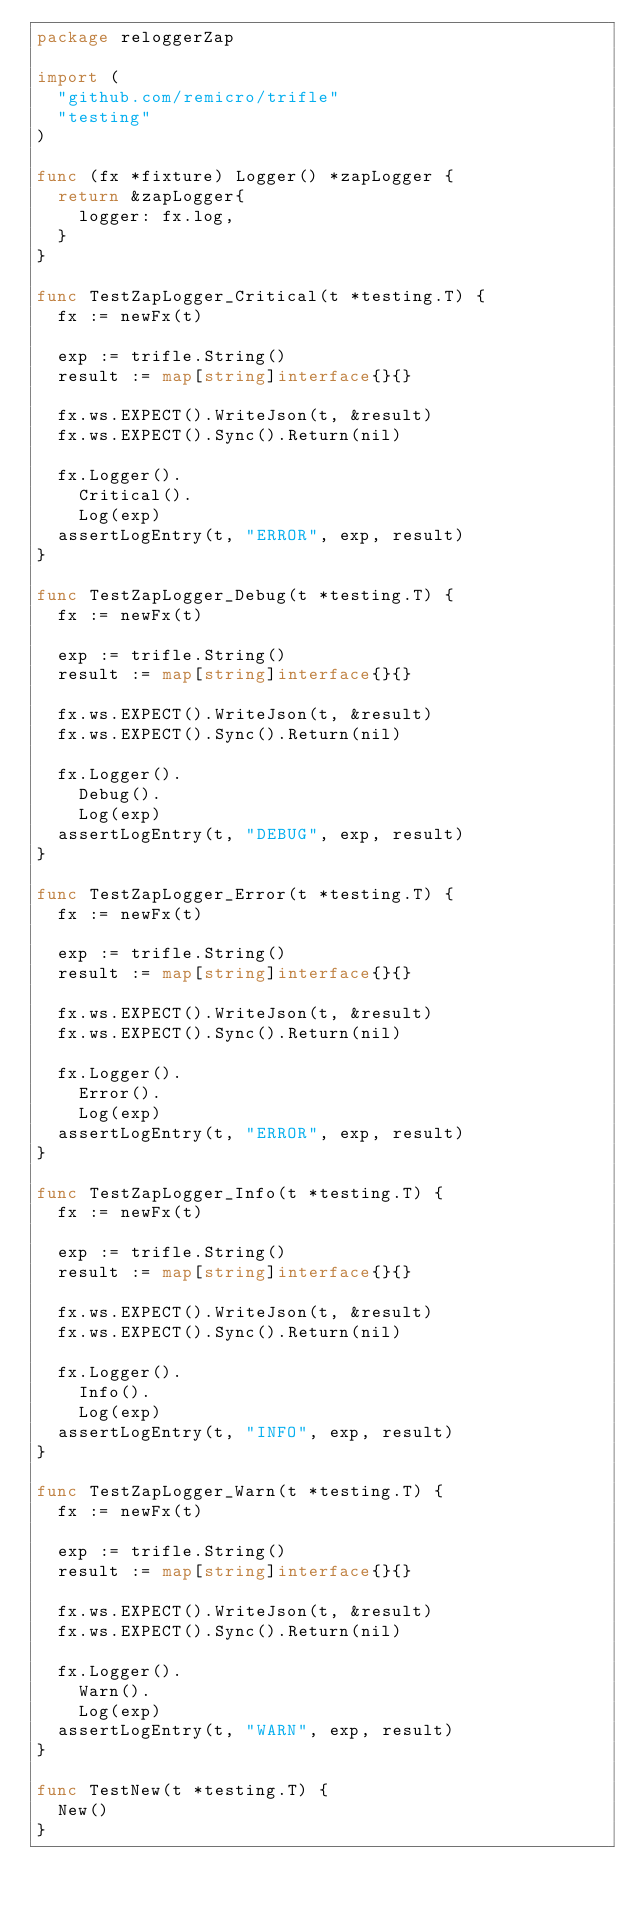Convert code to text. <code><loc_0><loc_0><loc_500><loc_500><_Go_>package reloggerZap

import (
	"github.com/remicro/trifle"
	"testing"
)

func (fx *fixture) Logger() *zapLogger {
	return &zapLogger{
		logger: fx.log,
	}
}

func TestZapLogger_Critical(t *testing.T) {
	fx := newFx(t)

	exp := trifle.String()
	result := map[string]interface{}{}

	fx.ws.EXPECT().WriteJson(t, &result)
	fx.ws.EXPECT().Sync().Return(nil)

	fx.Logger().
		Critical().
		Log(exp)
	assertLogEntry(t, "ERROR", exp, result)
}

func TestZapLogger_Debug(t *testing.T) {
	fx := newFx(t)

	exp := trifle.String()
	result := map[string]interface{}{}

	fx.ws.EXPECT().WriteJson(t, &result)
	fx.ws.EXPECT().Sync().Return(nil)

	fx.Logger().
		Debug().
		Log(exp)
	assertLogEntry(t, "DEBUG", exp, result)
}

func TestZapLogger_Error(t *testing.T) {
	fx := newFx(t)

	exp := trifle.String()
	result := map[string]interface{}{}

	fx.ws.EXPECT().WriteJson(t, &result)
	fx.ws.EXPECT().Sync().Return(nil)

	fx.Logger().
		Error().
		Log(exp)
	assertLogEntry(t, "ERROR", exp, result)
}

func TestZapLogger_Info(t *testing.T) {
	fx := newFx(t)

	exp := trifle.String()
	result := map[string]interface{}{}

	fx.ws.EXPECT().WriteJson(t, &result)
	fx.ws.EXPECT().Sync().Return(nil)

	fx.Logger().
		Info().
		Log(exp)
	assertLogEntry(t, "INFO", exp, result)
}

func TestZapLogger_Warn(t *testing.T) {
	fx := newFx(t)

	exp := trifle.String()
	result := map[string]interface{}{}

	fx.ws.EXPECT().WriteJson(t, &result)
	fx.ws.EXPECT().Sync().Return(nil)

	fx.Logger().
		Warn().
		Log(exp)
	assertLogEntry(t, "WARN", exp, result)
}

func TestNew(t *testing.T) {
	New()
}
</code> 